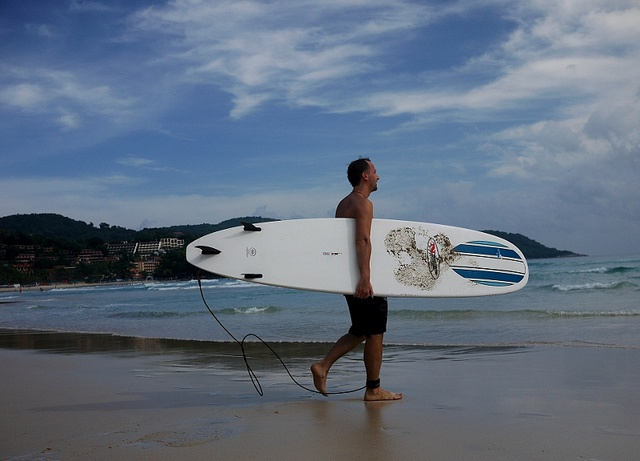Describe the objects in this image and their specific colors. I can see surfboard in navy, darkgray, gray, black, and lightgray tones and people in navy, black, maroon, brown, and gray tones in this image. 